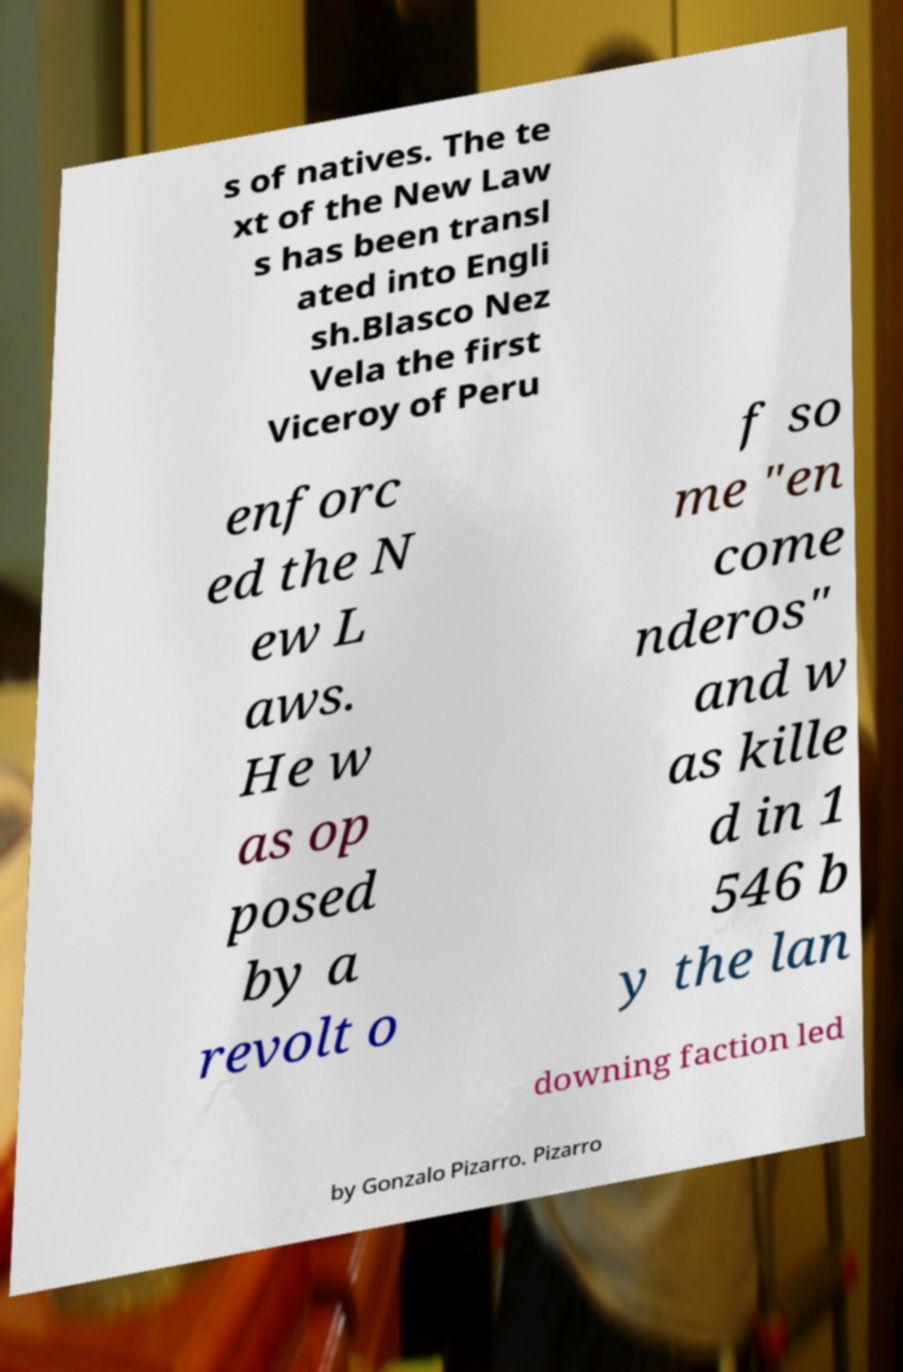What messages or text are displayed in this image? I need them in a readable, typed format. s of natives. The te xt of the New Law s has been transl ated into Engli sh.Blasco Nez Vela the first Viceroy of Peru enforc ed the N ew L aws. He w as op posed by a revolt o f so me "en come nderos" and w as kille d in 1 546 b y the lan downing faction led by Gonzalo Pizarro. Pizarro 